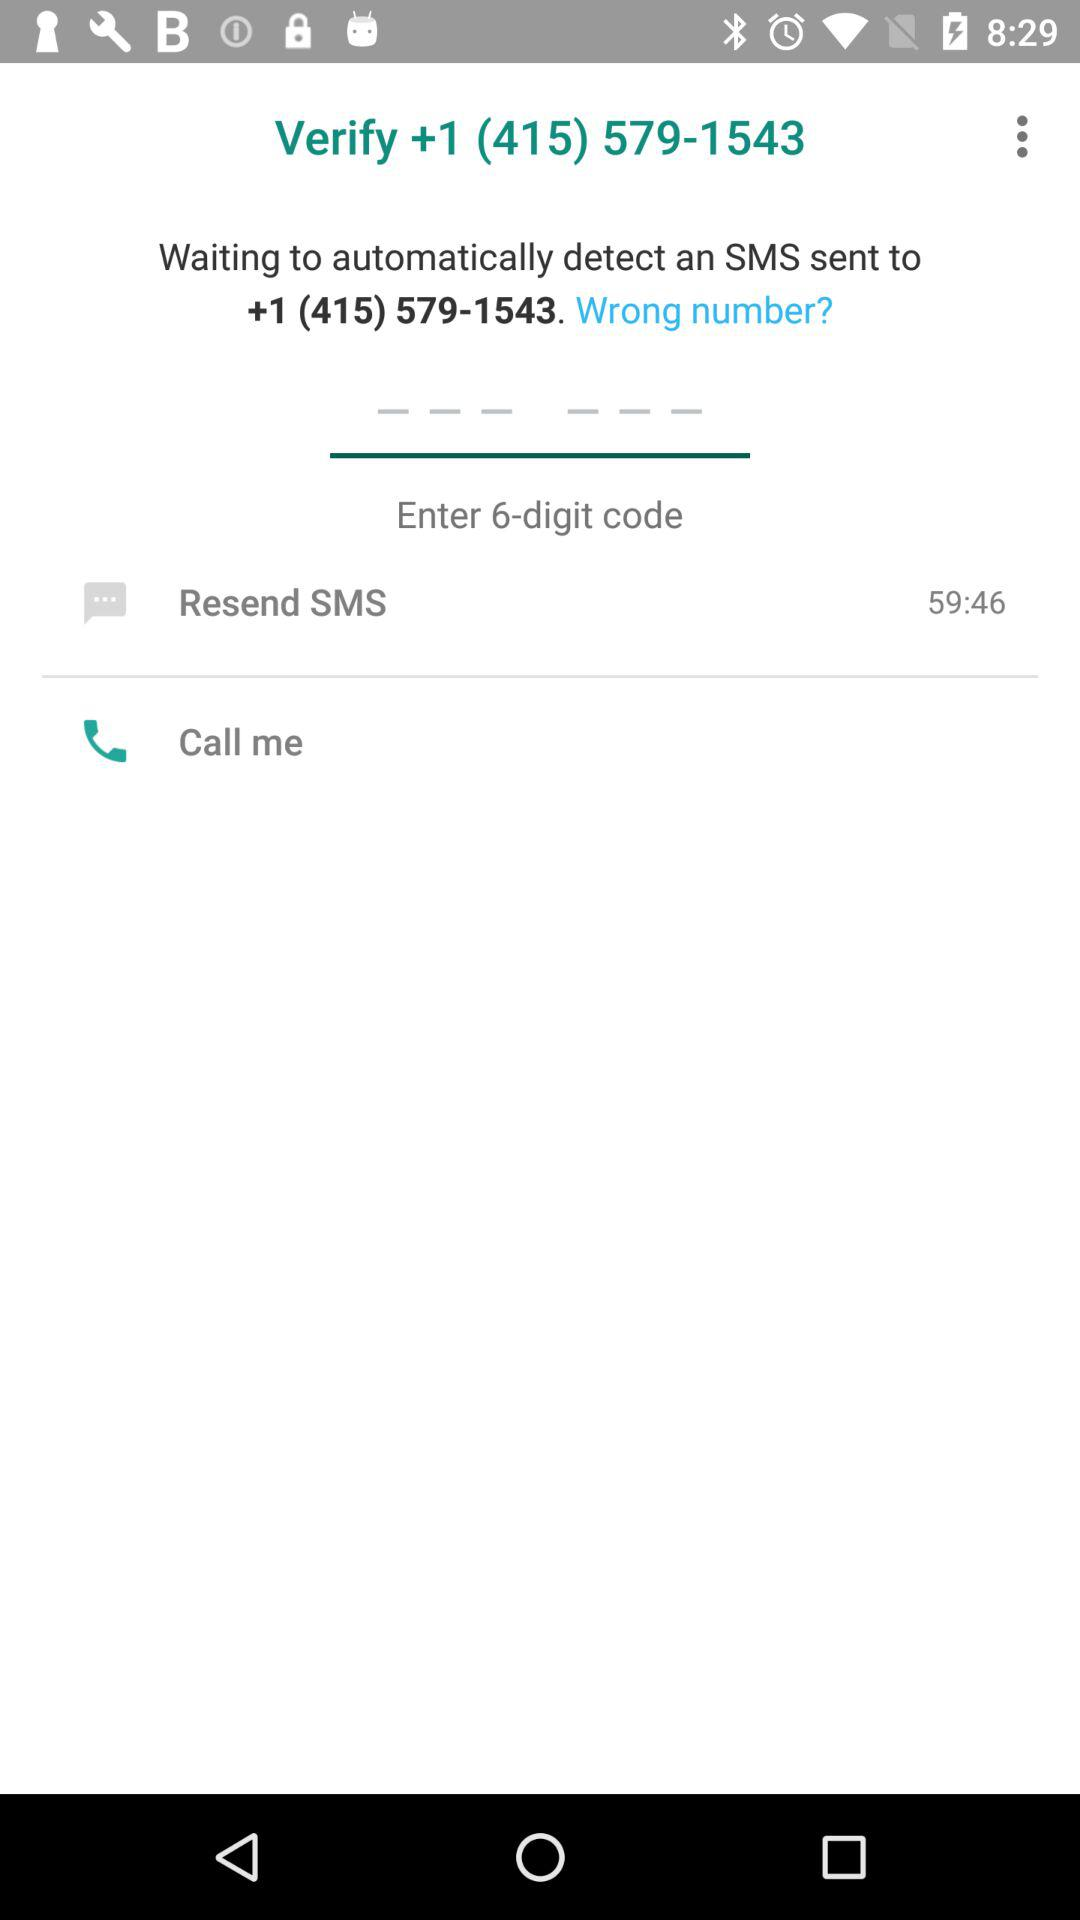On what number was the SMS sent? The number was +1 (415) 579-1543. 